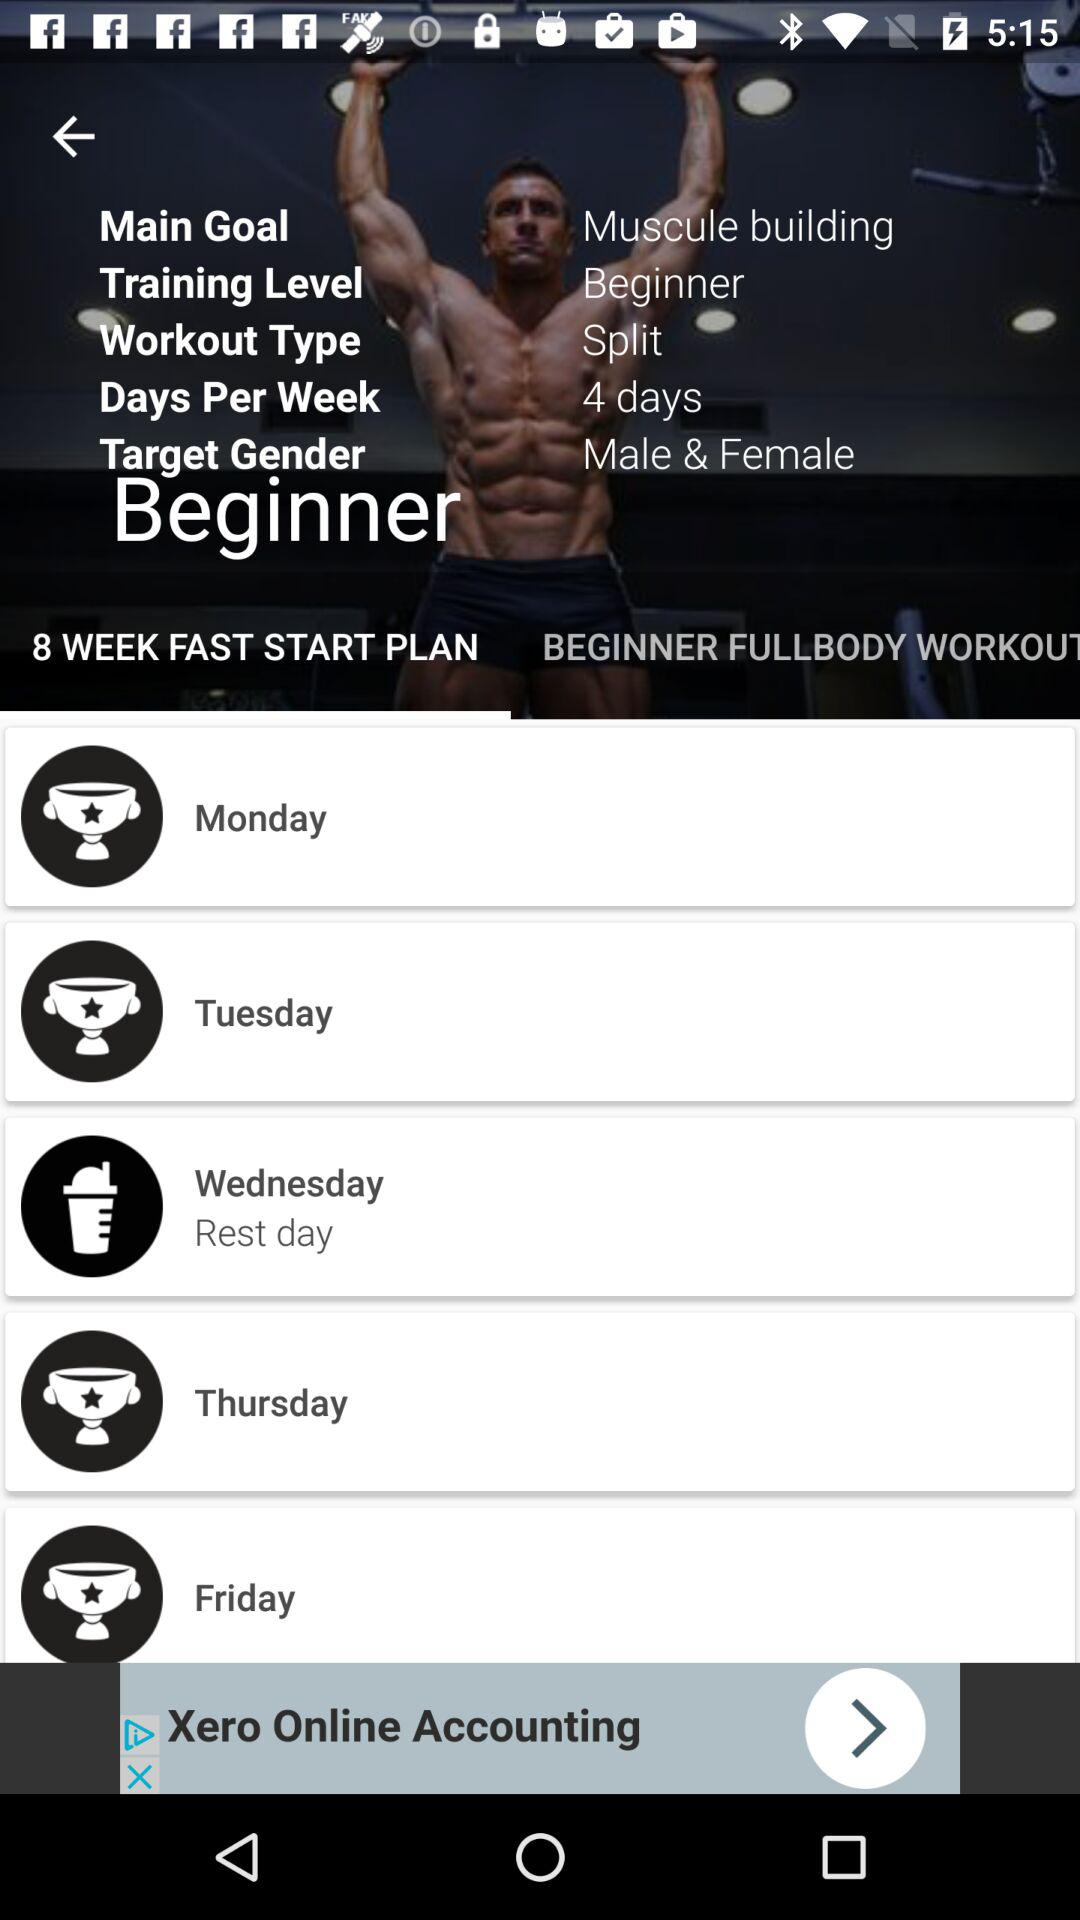How many days of the workout plan are rest days?
Answer the question using a single word or phrase. 1 